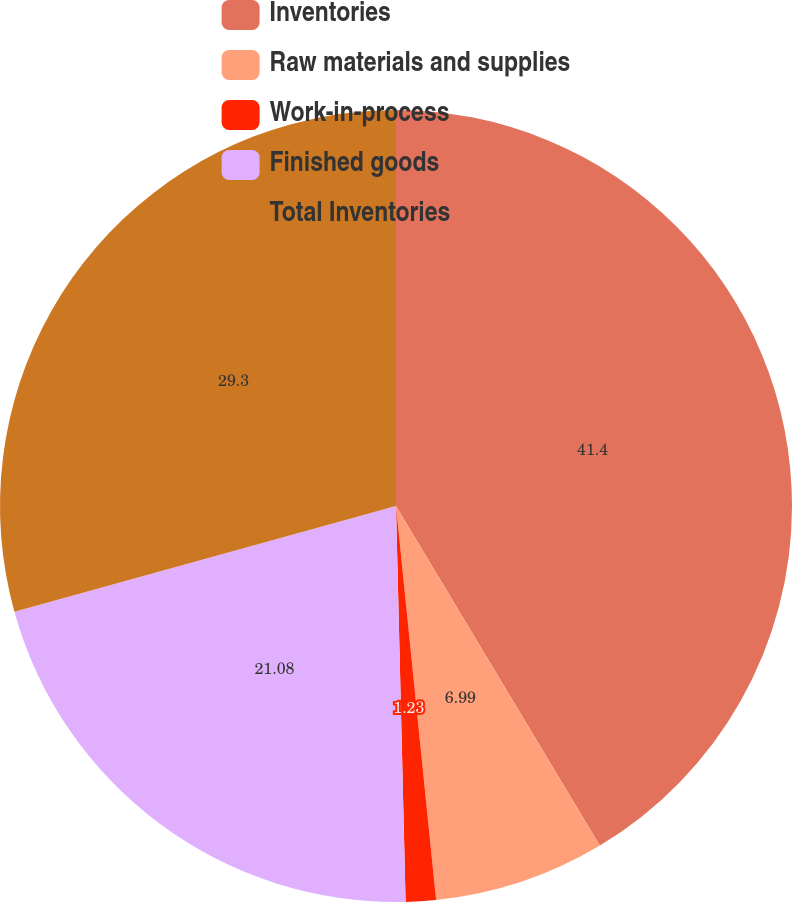Convert chart to OTSL. <chart><loc_0><loc_0><loc_500><loc_500><pie_chart><fcel>Inventories<fcel>Raw materials and supplies<fcel>Work-in-process<fcel>Finished goods<fcel>Total Inventories<nl><fcel>41.39%<fcel>6.99%<fcel>1.23%<fcel>21.08%<fcel>29.3%<nl></chart> 